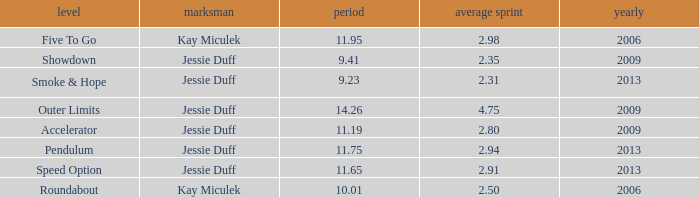What is the total years with average runs less than 4.75 and a time of 14.26? 0.0. Parse the table in full. {'header': ['level', 'marksman', 'period', 'average sprint', 'yearly'], 'rows': [['Five To Go', 'Kay Miculek', '11.95', '2.98', '2006'], ['Showdown', 'Jessie Duff', '9.41', '2.35', '2009'], ['Smoke & Hope', 'Jessie Duff', '9.23', '2.31', '2013'], ['Outer Limits', 'Jessie Duff', '14.26', '4.75', '2009'], ['Accelerator', 'Jessie Duff', '11.19', '2.80', '2009'], ['Pendulum', 'Jessie Duff', '11.75', '2.94', '2013'], ['Speed Option', 'Jessie Duff', '11.65', '2.91', '2013'], ['Roundabout', 'Kay Miculek', '10.01', '2.50', '2006']]} 